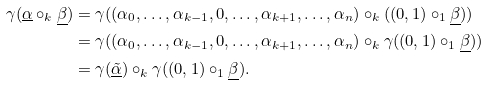<formula> <loc_0><loc_0><loc_500><loc_500>\gamma ( \underline { \alpha } \circ _ { k } \underline { \beta } ) & = \gamma ( ( \alpha _ { 0 } , \dots , \alpha _ { k - 1 } , 0 , \dots , \alpha _ { k + 1 } , \dots , \alpha _ { n } ) \circ _ { k } ( ( 0 , 1 ) \circ _ { 1 } \underline { \beta } ) ) \\ & = \gamma ( ( \alpha _ { 0 } , \dots , \alpha _ { k - 1 } , 0 , \dots , \alpha _ { k + 1 } , \dots , \alpha _ { n } ) \circ _ { k } \gamma ( ( 0 , 1 ) \circ _ { 1 } \underline { \beta } ) ) \\ & = \gamma ( \underline { \tilde { \alpha } } ) \circ _ { k } \gamma ( ( 0 , 1 ) \circ _ { 1 } \underline { \beta } ) .</formula> 